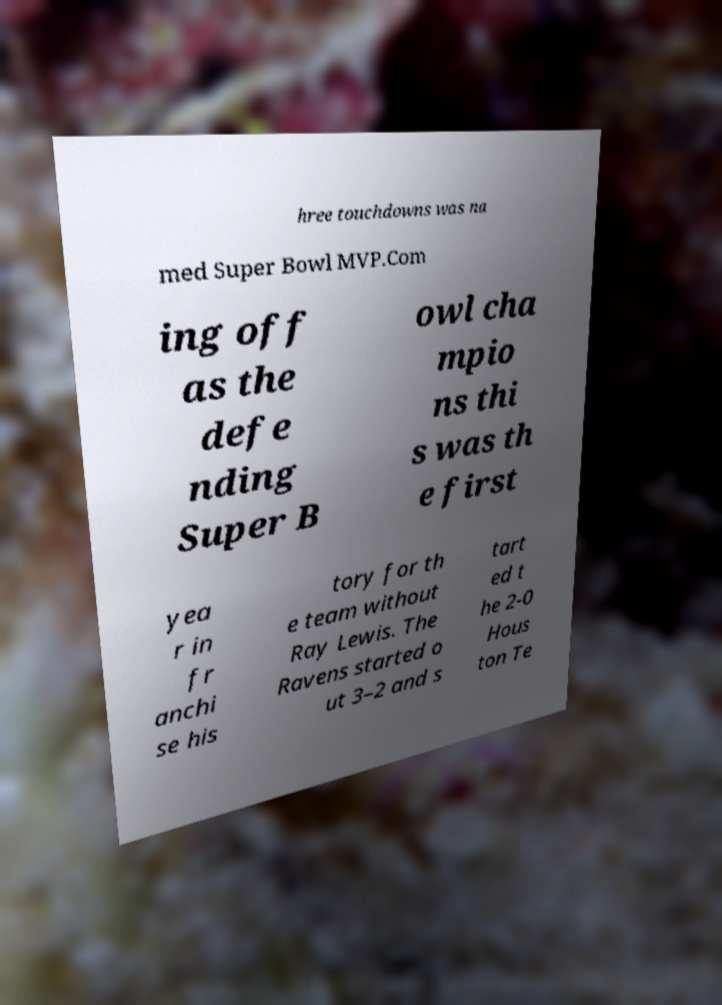What messages or text are displayed in this image? I need them in a readable, typed format. hree touchdowns was na med Super Bowl MVP.Com ing off as the defe nding Super B owl cha mpio ns thi s was th e first yea r in fr anchi se his tory for th e team without Ray Lewis. The Ravens started o ut 3–2 and s tart ed t he 2-0 Hous ton Te 